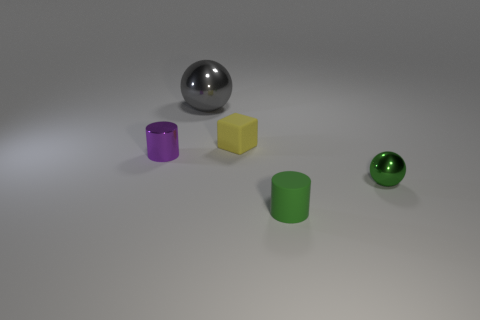Is the number of tiny metal objects left of the purple metallic cylinder the same as the number of small metal objects to the left of the small metal sphere?
Provide a succinct answer. No. Do the large shiny object and the thing to the left of the big gray object have the same shape?
Ensure brevity in your answer.  No. There is a small thing that is the same color as the tiny shiny ball; what is it made of?
Make the answer very short. Rubber. Is there anything else that is the same shape as the tiny yellow matte thing?
Your answer should be compact. No. Do the green sphere and the sphere that is behind the tiny metal ball have the same material?
Give a very brief answer. Yes. There is a small rubber object behind the metal ball on the right side of the rubber object behind the small purple metallic cylinder; what is its color?
Your response must be concise. Yellow. Is there any other thing that has the same size as the gray sphere?
Offer a terse response. No. There is a tiny sphere; does it have the same color as the small rubber object that is in front of the purple object?
Your answer should be very brief. Yes. What color is the metallic cylinder?
Make the answer very short. Purple. There is a small metallic thing on the right side of the gray shiny thing behind the small cylinder on the right side of the small yellow matte block; what shape is it?
Offer a terse response. Sphere. 